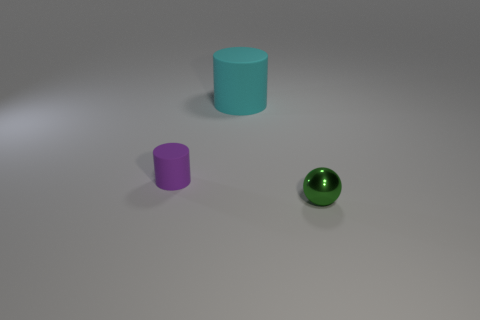Add 2 purple rubber things. How many objects exist? 5 Subtract all cylinders. How many objects are left? 1 Subtract 0 brown blocks. How many objects are left? 3 Subtract all small yellow rubber cubes. Subtract all tiny matte things. How many objects are left? 2 Add 1 big cyan matte cylinders. How many big cyan matte cylinders are left? 2 Add 3 cyan matte things. How many cyan matte things exist? 4 